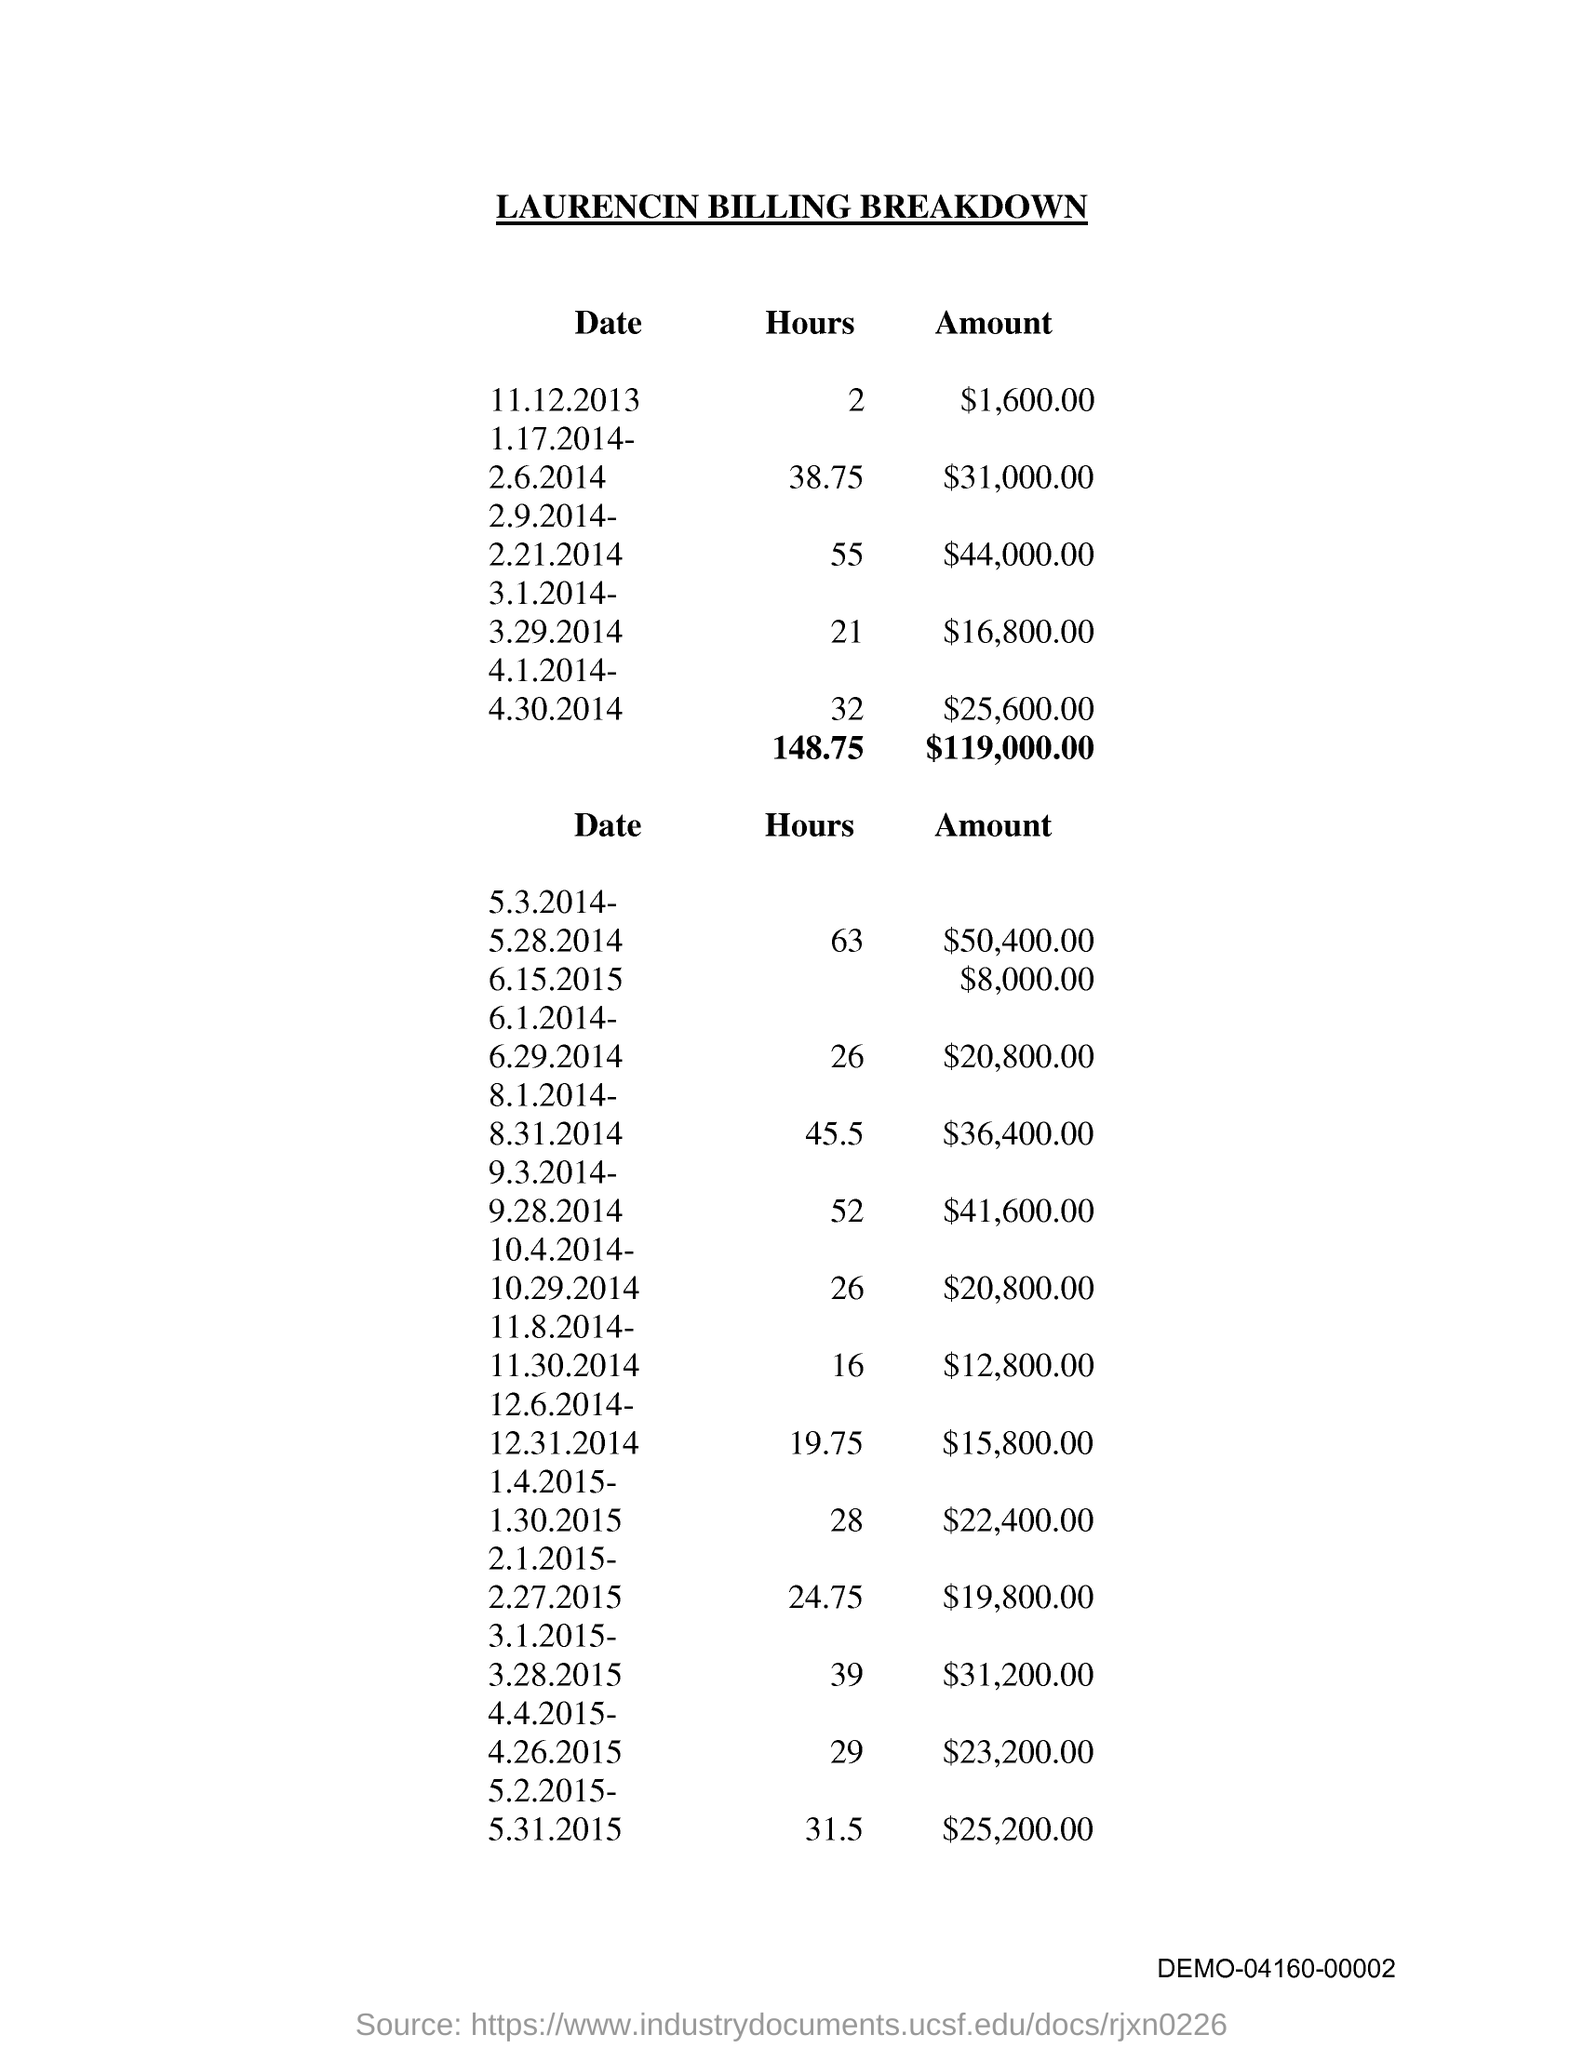What is the title of the document?
Provide a short and direct response. Laurencin Billing Breakdown. 